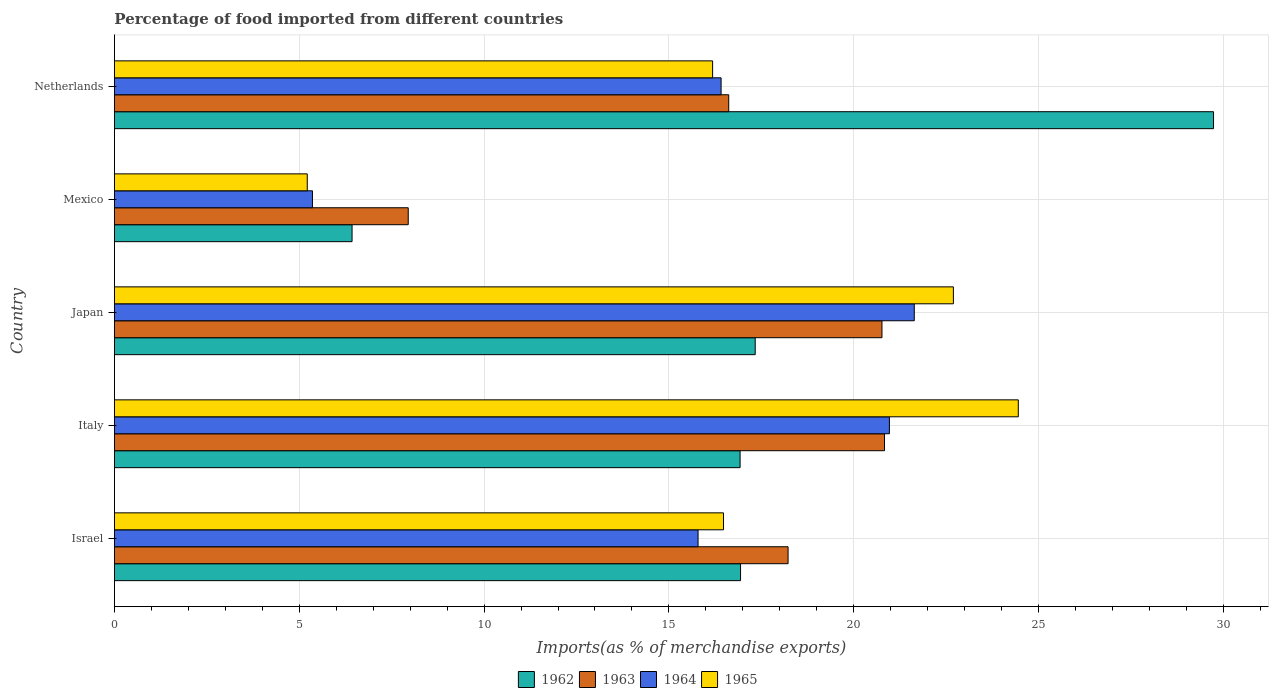Are the number of bars per tick equal to the number of legend labels?
Provide a short and direct response. Yes. Are the number of bars on each tick of the Y-axis equal?
Keep it short and to the point. Yes. How many bars are there on the 4th tick from the bottom?
Offer a terse response. 4. What is the label of the 3rd group of bars from the top?
Give a very brief answer. Japan. In how many cases, is the number of bars for a given country not equal to the number of legend labels?
Ensure brevity in your answer.  0. What is the percentage of imports to different countries in 1964 in Israel?
Your response must be concise. 15.79. Across all countries, what is the maximum percentage of imports to different countries in 1963?
Give a very brief answer. 20.83. Across all countries, what is the minimum percentage of imports to different countries in 1964?
Ensure brevity in your answer.  5.36. What is the total percentage of imports to different countries in 1963 in the graph?
Your answer should be very brief. 84.39. What is the difference between the percentage of imports to different countries in 1963 in Israel and that in Japan?
Your response must be concise. -2.54. What is the difference between the percentage of imports to different countries in 1965 in Israel and the percentage of imports to different countries in 1964 in Mexico?
Provide a short and direct response. 11.12. What is the average percentage of imports to different countries in 1962 per country?
Your answer should be very brief. 17.47. What is the difference between the percentage of imports to different countries in 1964 and percentage of imports to different countries in 1962 in Israel?
Keep it short and to the point. -1.15. What is the ratio of the percentage of imports to different countries in 1965 in Israel to that in Italy?
Your answer should be very brief. 0.67. Is the percentage of imports to different countries in 1965 in Israel less than that in Mexico?
Your response must be concise. No. Is the difference between the percentage of imports to different countries in 1964 in Italy and Japan greater than the difference between the percentage of imports to different countries in 1962 in Italy and Japan?
Make the answer very short. No. What is the difference between the highest and the second highest percentage of imports to different countries in 1963?
Give a very brief answer. 0.07. What is the difference between the highest and the lowest percentage of imports to different countries in 1963?
Provide a succinct answer. 12.88. In how many countries, is the percentage of imports to different countries in 1962 greater than the average percentage of imports to different countries in 1962 taken over all countries?
Make the answer very short. 1. Is it the case that in every country, the sum of the percentage of imports to different countries in 1962 and percentage of imports to different countries in 1964 is greater than the sum of percentage of imports to different countries in 1965 and percentage of imports to different countries in 1963?
Your response must be concise. No. What does the 3rd bar from the top in Italy represents?
Your answer should be compact. 1963. Are all the bars in the graph horizontal?
Provide a short and direct response. Yes. What is the difference between two consecutive major ticks on the X-axis?
Your answer should be very brief. 5. Does the graph contain any zero values?
Offer a very short reply. No. Does the graph contain grids?
Keep it short and to the point. Yes. How many legend labels are there?
Offer a very short reply. 4. What is the title of the graph?
Provide a succinct answer. Percentage of food imported from different countries. What is the label or title of the X-axis?
Offer a very short reply. Imports(as % of merchandise exports). What is the label or title of the Y-axis?
Provide a succinct answer. Country. What is the Imports(as % of merchandise exports) in 1962 in Israel?
Ensure brevity in your answer.  16.94. What is the Imports(as % of merchandise exports) in 1963 in Israel?
Offer a terse response. 18.22. What is the Imports(as % of merchandise exports) of 1964 in Israel?
Provide a succinct answer. 15.79. What is the Imports(as % of merchandise exports) in 1965 in Israel?
Provide a succinct answer. 16.48. What is the Imports(as % of merchandise exports) of 1962 in Italy?
Provide a succinct answer. 16.93. What is the Imports(as % of merchandise exports) in 1963 in Italy?
Give a very brief answer. 20.83. What is the Imports(as % of merchandise exports) in 1964 in Italy?
Your response must be concise. 20.97. What is the Imports(as % of merchandise exports) of 1965 in Italy?
Keep it short and to the point. 24.45. What is the Imports(as % of merchandise exports) in 1962 in Japan?
Offer a terse response. 17.34. What is the Imports(as % of merchandise exports) in 1963 in Japan?
Provide a succinct answer. 20.76. What is the Imports(as % of merchandise exports) of 1964 in Japan?
Keep it short and to the point. 21.64. What is the Imports(as % of merchandise exports) in 1965 in Japan?
Provide a succinct answer. 22.7. What is the Imports(as % of merchandise exports) of 1962 in Mexico?
Provide a short and direct response. 6.43. What is the Imports(as % of merchandise exports) in 1963 in Mexico?
Your answer should be compact. 7.95. What is the Imports(as % of merchandise exports) of 1964 in Mexico?
Make the answer very short. 5.36. What is the Imports(as % of merchandise exports) in 1965 in Mexico?
Give a very brief answer. 5.22. What is the Imports(as % of merchandise exports) in 1962 in Netherlands?
Keep it short and to the point. 29.73. What is the Imports(as % of merchandise exports) of 1963 in Netherlands?
Keep it short and to the point. 16.62. What is the Imports(as % of merchandise exports) of 1964 in Netherlands?
Ensure brevity in your answer.  16.41. What is the Imports(as % of merchandise exports) of 1965 in Netherlands?
Offer a very short reply. 16.18. Across all countries, what is the maximum Imports(as % of merchandise exports) of 1962?
Your response must be concise. 29.73. Across all countries, what is the maximum Imports(as % of merchandise exports) of 1963?
Keep it short and to the point. 20.83. Across all countries, what is the maximum Imports(as % of merchandise exports) of 1964?
Your answer should be compact. 21.64. Across all countries, what is the maximum Imports(as % of merchandise exports) of 1965?
Make the answer very short. 24.45. Across all countries, what is the minimum Imports(as % of merchandise exports) in 1962?
Offer a terse response. 6.43. Across all countries, what is the minimum Imports(as % of merchandise exports) of 1963?
Offer a very short reply. 7.95. Across all countries, what is the minimum Imports(as % of merchandise exports) of 1964?
Give a very brief answer. 5.36. Across all countries, what is the minimum Imports(as % of merchandise exports) of 1965?
Your answer should be compact. 5.22. What is the total Imports(as % of merchandise exports) in 1962 in the graph?
Give a very brief answer. 87.36. What is the total Imports(as % of merchandise exports) of 1963 in the graph?
Your answer should be compact. 84.39. What is the total Imports(as % of merchandise exports) in 1964 in the graph?
Make the answer very short. 80.16. What is the total Imports(as % of merchandise exports) of 1965 in the graph?
Your response must be concise. 85.03. What is the difference between the Imports(as % of merchandise exports) in 1962 in Israel and that in Italy?
Offer a terse response. 0.01. What is the difference between the Imports(as % of merchandise exports) in 1963 in Israel and that in Italy?
Make the answer very short. -2.61. What is the difference between the Imports(as % of merchandise exports) in 1964 in Israel and that in Italy?
Your answer should be compact. -5.18. What is the difference between the Imports(as % of merchandise exports) of 1965 in Israel and that in Italy?
Provide a short and direct response. -7.97. What is the difference between the Imports(as % of merchandise exports) of 1962 in Israel and that in Japan?
Keep it short and to the point. -0.4. What is the difference between the Imports(as % of merchandise exports) in 1963 in Israel and that in Japan?
Your answer should be very brief. -2.54. What is the difference between the Imports(as % of merchandise exports) in 1964 in Israel and that in Japan?
Make the answer very short. -5.85. What is the difference between the Imports(as % of merchandise exports) in 1965 in Israel and that in Japan?
Offer a very short reply. -6.22. What is the difference between the Imports(as % of merchandise exports) of 1962 in Israel and that in Mexico?
Provide a succinct answer. 10.51. What is the difference between the Imports(as % of merchandise exports) of 1963 in Israel and that in Mexico?
Keep it short and to the point. 10.28. What is the difference between the Imports(as % of merchandise exports) of 1964 in Israel and that in Mexico?
Ensure brevity in your answer.  10.43. What is the difference between the Imports(as % of merchandise exports) in 1965 in Israel and that in Mexico?
Offer a very short reply. 11.26. What is the difference between the Imports(as % of merchandise exports) of 1962 in Israel and that in Netherlands?
Make the answer very short. -12.8. What is the difference between the Imports(as % of merchandise exports) of 1963 in Israel and that in Netherlands?
Offer a very short reply. 1.61. What is the difference between the Imports(as % of merchandise exports) of 1964 in Israel and that in Netherlands?
Provide a short and direct response. -0.62. What is the difference between the Imports(as % of merchandise exports) in 1965 in Israel and that in Netherlands?
Provide a succinct answer. 0.3. What is the difference between the Imports(as % of merchandise exports) in 1962 in Italy and that in Japan?
Offer a very short reply. -0.41. What is the difference between the Imports(as % of merchandise exports) of 1963 in Italy and that in Japan?
Ensure brevity in your answer.  0.07. What is the difference between the Imports(as % of merchandise exports) in 1964 in Italy and that in Japan?
Make the answer very short. -0.67. What is the difference between the Imports(as % of merchandise exports) of 1965 in Italy and that in Japan?
Keep it short and to the point. 1.76. What is the difference between the Imports(as % of merchandise exports) of 1962 in Italy and that in Mexico?
Provide a short and direct response. 10.5. What is the difference between the Imports(as % of merchandise exports) of 1963 in Italy and that in Mexico?
Provide a succinct answer. 12.88. What is the difference between the Imports(as % of merchandise exports) of 1964 in Italy and that in Mexico?
Ensure brevity in your answer.  15.61. What is the difference between the Imports(as % of merchandise exports) in 1965 in Italy and that in Mexico?
Your answer should be compact. 19.24. What is the difference between the Imports(as % of merchandise exports) of 1962 in Italy and that in Netherlands?
Your response must be concise. -12.81. What is the difference between the Imports(as % of merchandise exports) in 1963 in Italy and that in Netherlands?
Your answer should be compact. 4.21. What is the difference between the Imports(as % of merchandise exports) of 1964 in Italy and that in Netherlands?
Provide a short and direct response. 4.55. What is the difference between the Imports(as % of merchandise exports) in 1965 in Italy and that in Netherlands?
Offer a very short reply. 8.27. What is the difference between the Imports(as % of merchandise exports) in 1962 in Japan and that in Mexico?
Your response must be concise. 10.91. What is the difference between the Imports(as % of merchandise exports) of 1963 in Japan and that in Mexico?
Ensure brevity in your answer.  12.82. What is the difference between the Imports(as % of merchandise exports) of 1964 in Japan and that in Mexico?
Ensure brevity in your answer.  16.28. What is the difference between the Imports(as % of merchandise exports) in 1965 in Japan and that in Mexico?
Your answer should be compact. 17.48. What is the difference between the Imports(as % of merchandise exports) in 1962 in Japan and that in Netherlands?
Give a very brief answer. -12.4. What is the difference between the Imports(as % of merchandise exports) in 1963 in Japan and that in Netherlands?
Provide a succinct answer. 4.15. What is the difference between the Imports(as % of merchandise exports) in 1964 in Japan and that in Netherlands?
Provide a short and direct response. 5.23. What is the difference between the Imports(as % of merchandise exports) in 1965 in Japan and that in Netherlands?
Provide a succinct answer. 6.51. What is the difference between the Imports(as % of merchandise exports) in 1962 in Mexico and that in Netherlands?
Your answer should be very brief. -23.31. What is the difference between the Imports(as % of merchandise exports) of 1963 in Mexico and that in Netherlands?
Offer a terse response. -8.67. What is the difference between the Imports(as % of merchandise exports) of 1964 in Mexico and that in Netherlands?
Provide a short and direct response. -11.05. What is the difference between the Imports(as % of merchandise exports) of 1965 in Mexico and that in Netherlands?
Provide a succinct answer. -10.97. What is the difference between the Imports(as % of merchandise exports) of 1962 in Israel and the Imports(as % of merchandise exports) of 1963 in Italy?
Your answer should be compact. -3.89. What is the difference between the Imports(as % of merchandise exports) of 1962 in Israel and the Imports(as % of merchandise exports) of 1964 in Italy?
Make the answer very short. -4.03. What is the difference between the Imports(as % of merchandise exports) of 1962 in Israel and the Imports(as % of merchandise exports) of 1965 in Italy?
Provide a short and direct response. -7.51. What is the difference between the Imports(as % of merchandise exports) of 1963 in Israel and the Imports(as % of merchandise exports) of 1964 in Italy?
Your answer should be compact. -2.74. What is the difference between the Imports(as % of merchandise exports) of 1963 in Israel and the Imports(as % of merchandise exports) of 1965 in Italy?
Offer a terse response. -6.23. What is the difference between the Imports(as % of merchandise exports) in 1964 in Israel and the Imports(as % of merchandise exports) in 1965 in Italy?
Provide a short and direct response. -8.66. What is the difference between the Imports(as % of merchandise exports) in 1962 in Israel and the Imports(as % of merchandise exports) in 1963 in Japan?
Offer a terse response. -3.83. What is the difference between the Imports(as % of merchandise exports) of 1962 in Israel and the Imports(as % of merchandise exports) of 1964 in Japan?
Your answer should be compact. -4.7. What is the difference between the Imports(as % of merchandise exports) of 1962 in Israel and the Imports(as % of merchandise exports) of 1965 in Japan?
Make the answer very short. -5.76. What is the difference between the Imports(as % of merchandise exports) in 1963 in Israel and the Imports(as % of merchandise exports) in 1964 in Japan?
Offer a very short reply. -3.41. What is the difference between the Imports(as % of merchandise exports) in 1963 in Israel and the Imports(as % of merchandise exports) in 1965 in Japan?
Your answer should be very brief. -4.47. What is the difference between the Imports(as % of merchandise exports) of 1964 in Israel and the Imports(as % of merchandise exports) of 1965 in Japan?
Your answer should be compact. -6.91. What is the difference between the Imports(as % of merchandise exports) in 1962 in Israel and the Imports(as % of merchandise exports) in 1963 in Mexico?
Your answer should be very brief. 8.99. What is the difference between the Imports(as % of merchandise exports) in 1962 in Israel and the Imports(as % of merchandise exports) in 1964 in Mexico?
Offer a terse response. 11.58. What is the difference between the Imports(as % of merchandise exports) of 1962 in Israel and the Imports(as % of merchandise exports) of 1965 in Mexico?
Ensure brevity in your answer.  11.72. What is the difference between the Imports(as % of merchandise exports) in 1963 in Israel and the Imports(as % of merchandise exports) in 1964 in Mexico?
Offer a very short reply. 12.87. What is the difference between the Imports(as % of merchandise exports) of 1963 in Israel and the Imports(as % of merchandise exports) of 1965 in Mexico?
Offer a very short reply. 13.01. What is the difference between the Imports(as % of merchandise exports) of 1964 in Israel and the Imports(as % of merchandise exports) of 1965 in Mexico?
Your answer should be very brief. 10.57. What is the difference between the Imports(as % of merchandise exports) of 1962 in Israel and the Imports(as % of merchandise exports) of 1963 in Netherlands?
Keep it short and to the point. 0.32. What is the difference between the Imports(as % of merchandise exports) of 1962 in Israel and the Imports(as % of merchandise exports) of 1964 in Netherlands?
Make the answer very short. 0.53. What is the difference between the Imports(as % of merchandise exports) in 1962 in Israel and the Imports(as % of merchandise exports) in 1965 in Netherlands?
Your answer should be compact. 0.76. What is the difference between the Imports(as % of merchandise exports) in 1963 in Israel and the Imports(as % of merchandise exports) in 1964 in Netherlands?
Provide a short and direct response. 1.81. What is the difference between the Imports(as % of merchandise exports) of 1963 in Israel and the Imports(as % of merchandise exports) of 1965 in Netherlands?
Make the answer very short. 2.04. What is the difference between the Imports(as % of merchandise exports) of 1964 in Israel and the Imports(as % of merchandise exports) of 1965 in Netherlands?
Offer a terse response. -0.39. What is the difference between the Imports(as % of merchandise exports) in 1962 in Italy and the Imports(as % of merchandise exports) in 1963 in Japan?
Provide a short and direct response. -3.84. What is the difference between the Imports(as % of merchandise exports) of 1962 in Italy and the Imports(as % of merchandise exports) of 1964 in Japan?
Provide a short and direct response. -4.71. What is the difference between the Imports(as % of merchandise exports) in 1962 in Italy and the Imports(as % of merchandise exports) in 1965 in Japan?
Offer a very short reply. -5.77. What is the difference between the Imports(as % of merchandise exports) of 1963 in Italy and the Imports(as % of merchandise exports) of 1964 in Japan?
Provide a short and direct response. -0.81. What is the difference between the Imports(as % of merchandise exports) in 1963 in Italy and the Imports(as % of merchandise exports) in 1965 in Japan?
Ensure brevity in your answer.  -1.86. What is the difference between the Imports(as % of merchandise exports) of 1964 in Italy and the Imports(as % of merchandise exports) of 1965 in Japan?
Your answer should be compact. -1.73. What is the difference between the Imports(as % of merchandise exports) of 1962 in Italy and the Imports(as % of merchandise exports) of 1963 in Mexico?
Offer a very short reply. 8.98. What is the difference between the Imports(as % of merchandise exports) in 1962 in Italy and the Imports(as % of merchandise exports) in 1964 in Mexico?
Your answer should be compact. 11.57. What is the difference between the Imports(as % of merchandise exports) of 1962 in Italy and the Imports(as % of merchandise exports) of 1965 in Mexico?
Your answer should be very brief. 11.71. What is the difference between the Imports(as % of merchandise exports) of 1963 in Italy and the Imports(as % of merchandise exports) of 1964 in Mexico?
Your answer should be compact. 15.48. What is the difference between the Imports(as % of merchandise exports) of 1963 in Italy and the Imports(as % of merchandise exports) of 1965 in Mexico?
Ensure brevity in your answer.  15.62. What is the difference between the Imports(as % of merchandise exports) in 1964 in Italy and the Imports(as % of merchandise exports) in 1965 in Mexico?
Your answer should be very brief. 15.75. What is the difference between the Imports(as % of merchandise exports) of 1962 in Italy and the Imports(as % of merchandise exports) of 1963 in Netherlands?
Make the answer very short. 0.31. What is the difference between the Imports(as % of merchandise exports) in 1962 in Italy and the Imports(as % of merchandise exports) in 1964 in Netherlands?
Keep it short and to the point. 0.51. What is the difference between the Imports(as % of merchandise exports) in 1962 in Italy and the Imports(as % of merchandise exports) in 1965 in Netherlands?
Provide a succinct answer. 0.74. What is the difference between the Imports(as % of merchandise exports) in 1963 in Italy and the Imports(as % of merchandise exports) in 1964 in Netherlands?
Offer a terse response. 4.42. What is the difference between the Imports(as % of merchandise exports) in 1963 in Italy and the Imports(as % of merchandise exports) in 1965 in Netherlands?
Your response must be concise. 4.65. What is the difference between the Imports(as % of merchandise exports) in 1964 in Italy and the Imports(as % of merchandise exports) in 1965 in Netherlands?
Give a very brief answer. 4.78. What is the difference between the Imports(as % of merchandise exports) of 1962 in Japan and the Imports(as % of merchandise exports) of 1963 in Mexico?
Offer a terse response. 9.39. What is the difference between the Imports(as % of merchandise exports) in 1962 in Japan and the Imports(as % of merchandise exports) in 1964 in Mexico?
Offer a terse response. 11.98. What is the difference between the Imports(as % of merchandise exports) in 1962 in Japan and the Imports(as % of merchandise exports) in 1965 in Mexico?
Provide a succinct answer. 12.12. What is the difference between the Imports(as % of merchandise exports) in 1963 in Japan and the Imports(as % of merchandise exports) in 1964 in Mexico?
Provide a succinct answer. 15.41. What is the difference between the Imports(as % of merchandise exports) in 1963 in Japan and the Imports(as % of merchandise exports) in 1965 in Mexico?
Your answer should be compact. 15.55. What is the difference between the Imports(as % of merchandise exports) of 1964 in Japan and the Imports(as % of merchandise exports) of 1965 in Mexico?
Offer a terse response. 16.42. What is the difference between the Imports(as % of merchandise exports) in 1962 in Japan and the Imports(as % of merchandise exports) in 1963 in Netherlands?
Provide a short and direct response. 0.72. What is the difference between the Imports(as % of merchandise exports) in 1962 in Japan and the Imports(as % of merchandise exports) in 1964 in Netherlands?
Your answer should be very brief. 0.92. What is the difference between the Imports(as % of merchandise exports) in 1962 in Japan and the Imports(as % of merchandise exports) in 1965 in Netherlands?
Give a very brief answer. 1.15. What is the difference between the Imports(as % of merchandise exports) of 1963 in Japan and the Imports(as % of merchandise exports) of 1964 in Netherlands?
Ensure brevity in your answer.  4.35. What is the difference between the Imports(as % of merchandise exports) in 1963 in Japan and the Imports(as % of merchandise exports) in 1965 in Netherlands?
Make the answer very short. 4.58. What is the difference between the Imports(as % of merchandise exports) in 1964 in Japan and the Imports(as % of merchandise exports) in 1965 in Netherlands?
Keep it short and to the point. 5.46. What is the difference between the Imports(as % of merchandise exports) in 1962 in Mexico and the Imports(as % of merchandise exports) in 1963 in Netherlands?
Your answer should be compact. -10.19. What is the difference between the Imports(as % of merchandise exports) in 1962 in Mexico and the Imports(as % of merchandise exports) in 1964 in Netherlands?
Ensure brevity in your answer.  -9.98. What is the difference between the Imports(as % of merchandise exports) in 1962 in Mexico and the Imports(as % of merchandise exports) in 1965 in Netherlands?
Offer a terse response. -9.75. What is the difference between the Imports(as % of merchandise exports) of 1963 in Mexico and the Imports(as % of merchandise exports) of 1964 in Netherlands?
Ensure brevity in your answer.  -8.46. What is the difference between the Imports(as % of merchandise exports) of 1963 in Mexico and the Imports(as % of merchandise exports) of 1965 in Netherlands?
Make the answer very short. -8.23. What is the difference between the Imports(as % of merchandise exports) in 1964 in Mexico and the Imports(as % of merchandise exports) in 1965 in Netherlands?
Offer a very short reply. -10.83. What is the average Imports(as % of merchandise exports) in 1962 per country?
Your answer should be very brief. 17.47. What is the average Imports(as % of merchandise exports) of 1963 per country?
Offer a very short reply. 16.88. What is the average Imports(as % of merchandise exports) of 1964 per country?
Ensure brevity in your answer.  16.03. What is the average Imports(as % of merchandise exports) of 1965 per country?
Your answer should be compact. 17.01. What is the difference between the Imports(as % of merchandise exports) of 1962 and Imports(as % of merchandise exports) of 1963 in Israel?
Provide a succinct answer. -1.29. What is the difference between the Imports(as % of merchandise exports) in 1962 and Imports(as % of merchandise exports) in 1964 in Israel?
Offer a very short reply. 1.15. What is the difference between the Imports(as % of merchandise exports) in 1962 and Imports(as % of merchandise exports) in 1965 in Israel?
Offer a very short reply. 0.46. What is the difference between the Imports(as % of merchandise exports) in 1963 and Imports(as % of merchandise exports) in 1964 in Israel?
Offer a very short reply. 2.43. What is the difference between the Imports(as % of merchandise exports) in 1963 and Imports(as % of merchandise exports) in 1965 in Israel?
Your answer should be compact. 1.75. What is the difference between the Imports(as % of merchandise exports) in 1964 and Imports(as % of merchandise exports) in 1965 in Israel?
Offer a terse response. -0.69. What is the difference between the Imports(as % of merchandise exports) of 1962 and Imports(as % of merchandise exports) of 1963 in Italy?
Make the answer very short. -3.91. What is the difference between the Imports(as % of merchandise exports) in 1962 and Imports(as % of merchandise exports) in 1964 in Italy?
Provide a short and direct response. -4.04. What is the difference between the Imports(as % of merchandise exports) in 1962 and Imports(as % of merchandise exports) in 1965 in Italy?
Make the answer very short. -7.53. What is the difference between the Imports(as % of merchandise exports) in 1963 and Imports(as % of merchandise exports) in 1964 in Italy?
Ensure brevity in your answer.  -0.13. What is the difference between the Imports(as % of merchandise exports) in 1963 and Imports(as % of merchandise exports) in 1965 in Italy?
Keep it short and to the point. -3.62. What is the difference between the Imports(as % of merchandise exports) of 1964 and Imports(as % of merchandise exports) of 1965 in Italy?
Your answer should be compact. -3.49. What is the difference between the Imports(as % of merchandise exports) in 1962 and Imports(as % of merchandise exports) in 1963 in Japan?
Offer a terse response. -3.43. What is the difference between the Imports(as % of merchandise exports) in 1962 and Imports(as % of merchandise exports) in 1964 in Japan?
Your answer should be very brief. -4.3. What is the difference between the Imports(as % of merchandise exports) in 1962 and Imports(as % of merchandise exports) in 1965 in Japan?
Your response must be concise. -5.36. What is the difference between the Imports(as % of merchandise exports) in 1963 and Imports(as % of merchandise exports) in 1964 in Japan?
Offer a very short reply. -0.87. What is the difference between the Imports(as % of merchandise exports) in 1963 and Imports(as % of merchandise exports) in 1965 in Japan?
Provide a succinct answer. -1.93. What is the difference between the Imports(as % of merchandise exports) in 1964 and Imports(as % of merchandise exports) in 1965 in Japan?
Offer a very short reply. -1.06. What is the difference between the Imports(as % of merchandise exports) in 1962 and Imports(as % of merchandise exports) in 1963 in Mexico?
Keep it short and to the point. -1.52. What is the difference between the Imports(as % of merchandise exports) in 1962 and Imports(as % of merchandise exports) in 1964 in Mexico?
Offer a terse response. 1.07. What is the difference between the Imports(as % of merchandise exports) in 1962 and Imports(as % of merchandise exports) in 1965 in Mexico?
Keep it short and to the point. 1.21. What is the difference between the Imports(as % of merchandise exports) of 1963 and Imports(as % of merchandise exports) of 1964 in Mexico?
Keep it short and to the point. 2.59. What is the difference between the Imports(as % of merchandise exports) in 1963 and Imports(as % of merchandise exports) in 1965 in Mexico?
Your answer should be compact. 2.73. What is the difference between the Imports(as % of merchandise exports) in 1964 and Imports(as % of merchandise exports) in 1965 in Mexico?
Your answer should be compact. 0.14. What is the difference between the Imports(as % of merchandise exports) in 1962 and Imports(as % of merchandise exports) in 1963 in Netherlands?
Provide a succinct answer. 13.12. What is the difference between the Imports(as % of merchandise exports) of 1962 and Imports(as % of merchandise exports) of 1964 in Netherlands?
Offer a terse response. 13.32. What is the difference between the Imports(as % of merchandise exports) of 1962 and Imports(as % of merchandise exports) of 1965 in Netherlands?
Offer a very short reply. 13.55. What is the difference between the Imports(as % of merchandise exports) in 1963 and Imports(as % of merchandise exports) in 1964 in Netherlands?
Your answer should be very brief. 0.21. What is the difference between the Imports(as % of merchandise exports) of 1963 and Imports(as % of merchandise exports) of 1965 in Netherlands?
Make the answer very short. 0.44. What is the difference between the Imports(as % of merchandise exports) of 1964 and Imports(as % of merchandise exports) of 1965 in Netherlands?
Your answer should be compact. 0.23. What is the ratio of the Imports(as % of merchandise exports) in 1963 in Israel to that in Italy?
Offer a very short reply. 0.87. What is the ratio of the Imports(as % of merchandise exports) in 1964 in Israel to that in Italy?
Your response must be concise. 0.75. What is the ratio of the Imports(as % of merchandise exports) in 1965 in Israel to that in Italy?
Provide a short and direct response. 0.67. What is the ratio of the Imports(as % of merchandise exports) of 1962 in Israel to that in Japan?
Provide a succinct answer. 0.98. What is the ratio of the Imports(as % of merchandise exports) of 1963 in Israel to that in Japan?
Ensure brevity in your answer.  0.88. What is the ratio of the Imports(as % of merchandise exports) of 1964 in Israel to that in Japan?
Your response must be concise. 0.73. What is the ratio of the Imports(as % of merchandise exports) in 1965 in Israel to that in Japan?
Offer a terse response. 0.73. What is the ratio of the Imports(as % of merchandise exports) of 1962 in Israel to that in Mexico?
Your answer should be compact. 2.63. What is the ratio of the Imports(as % of merchandise exports) of 1963 in Israel to that in Mexico?
Give a very brief answer. 2.29. What is the ratio of the Imports(as % of merchandise exports) in 1964 in Israel to that in Mexico?
Your answer should be compact. 2.95. What is the ratio of the Imports(as % of merchandise exports) of 1965 in Israel to that in Mexico?
Give a very brief answer. 3.16. What is the ratio of the Imports(as % of merchandise exports) in 1962 in Israel to that in Netherlands?
Your answer should be very brief. 0.57. What is the ratio of the Imports(as % of merchandise exports) in 1963 in Israel to that in Netherlands?
Provide a succinct answer. 1.1. What is the ratio of the Imports(as % of merchandise exports) in 1965 in Israel to that in Netherlands?
Your answer should be very brief. 1.02. What is the ratio of the Imports(as % of merchandise exports) in 1962 in Italy to that in Japan?
Offer a very short reply. 0.98. What is the ratio of the Imports(as % of merchandise exports) in 1964 in Italy to that in Japan?
Offer a terse response. 0.97. What is the ratio of the Imports(as % of merchandise exports) in 1965 in Italy to that in Japan?
Provide a succinct answer. 1.08. What is the ratio of the Imports(as % of merchandise exports) of 1962 in Italy to that in Mexico?
Ensure brevity in your answer.  2.63. What is the ratio of the Imports(as % of merchandise exports) in 1963 in Italy to that in Mexico?
Offer a terse response. 2.62. What is the ratio of the Imports(as % of merchandise exports) of 1964 in Italy to that in Mexico?
Ensure brevity in your answer.  3.91. What is the ratio of the Imports(as % of merchandise exports) of 1965 in Italy to that in Mexico?
Provide a succinct answer. 4.69. What is the ratio of the Imports(as % of merchandise exports) in 1962 in Italy to that in Netherlands?
Give a very brief answer. 0.57. What is the ratio of the Imports(as % of merchandise exports) in 1963 in Italy to that in Netherlands?
Keep it short and to the point. 1.25. What is the ratio of the Imports(as % of merchandise exports) in 1964 in Italy to that in Netherlands?
Ensure brevity in your answer.  1.28. What is the ratio of the Imports(as % of merchandise exports) in 1965 in Italy to that in Netherlands?
Your response must be concise. 1.51. What is the ratio of the Imports(as % of merchandise exports) of 1962 in Japan to that in Mexico?
Provide a short and direct response. 2.7. What is the ratio of the Imports(as % of merchandise exports) in 1963 in Japan to that in Mexico?
Your answer should be very brief. 2.61. What is the ratio of the Imports(as % of merchandise exports) of 1964 in Japan to that in Mexico?
Offer a terse response. 4.04. What is the ratio of the Imports(as % of merchandise exports) in 1965 in Japan to that in Mexico?
Make the answer very short. 4.35. What is the ratio of the Imports(as % of merchandise exports) in 1962 in Japan to that in Netherlands?
Your answer should be very brief. 0.58. What is the ratio of the Imports(as % of merchandise exports) of 1963 in Japan to that in Netherlands?
Provide a succinct answer. 1.25. What is the ratio of the Imports(as % of merchandise exports) of 1964 in Japan to that in Netherlands?
Give a very brief answer. 1.32. What is the ratio of the Imports(as % of merchandise exports) in 1965 in Japan to that in Netherlands?
Your answer should be compact. 1.4. What is the ratio of the Imports(as % of merchandise exports) in 1962 in Mexico to that in Netherlands?
Your answer should be very brief. 0.22. What is the ratio of the Imports(as % of merchandise exports) of 1963 in Mexico to that in Netherlands?
Your answer should be very brief. 0.48. What is the ratio of the Imports(as % of merchandise exports) of 1964 in Mexico to that in Netherlands?
Give a very brief answer. 0.33. What is the ratio of the Imports(as % of merchandise exports) of 1965 in Mexico to that in Netherlands?
Make the answer very short. 0.32. What is the difference between the highest and the second highest Imports(as % of merchandise exports) in 1962?
Offer a terse response. 12.4. What is the difference between the highest and the second highest Imports(as % of merchandise exports) of 1963?
Provide a succinct answer. 0.07. What is the difference between the highest and the second highest Imports(as % of merchandise exports) in 1964?
Give a very brief answer. 0.67. What is the difference between the highest and the second highest Imports(as % of merchandise exports) of 1965?
Offer a terse response. 1.76. What is the difference between the highest and the lowest Imports(as % of merchandise exports) of 1962?
Your answer should be very brief. 23.31. What is the difference between the highest and the lowest Imports(as % of merchandise exports) in 1963?
Your response must be concise. 12.88. What is the difference between the highest and the lowest Imports(as % of merchandise exports) of 1964?
Offer a terse response. 16.28. What is the difference between the highest and the lowest Imports(as % of merchandise exports) in 1965?
Your response must be concise. 19.24. 